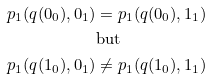Convert formula to latex. <formula><loc_0><loc_0><loc_500><loc_500>p _ { 1 } ( q ( 0 _ { 0 } ) , 0 _ { 1 } ) & = p _ { 1 } ( q ( 0 _ { 0 } ) , 1 _ { 1 } ) \\ & \text {but} \\ p _ { 1 } ( q ( 1 _ { 0 } ) , 0 _ { 1 } ) & \neq p _ { 1 } ( q ( 1 _ { 0 } ) , 1 _ { 1 } )</formula> 